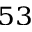<formula> <loc_0><loc_0><loc_500><loc_500>^ { 5 3 }</formula> 